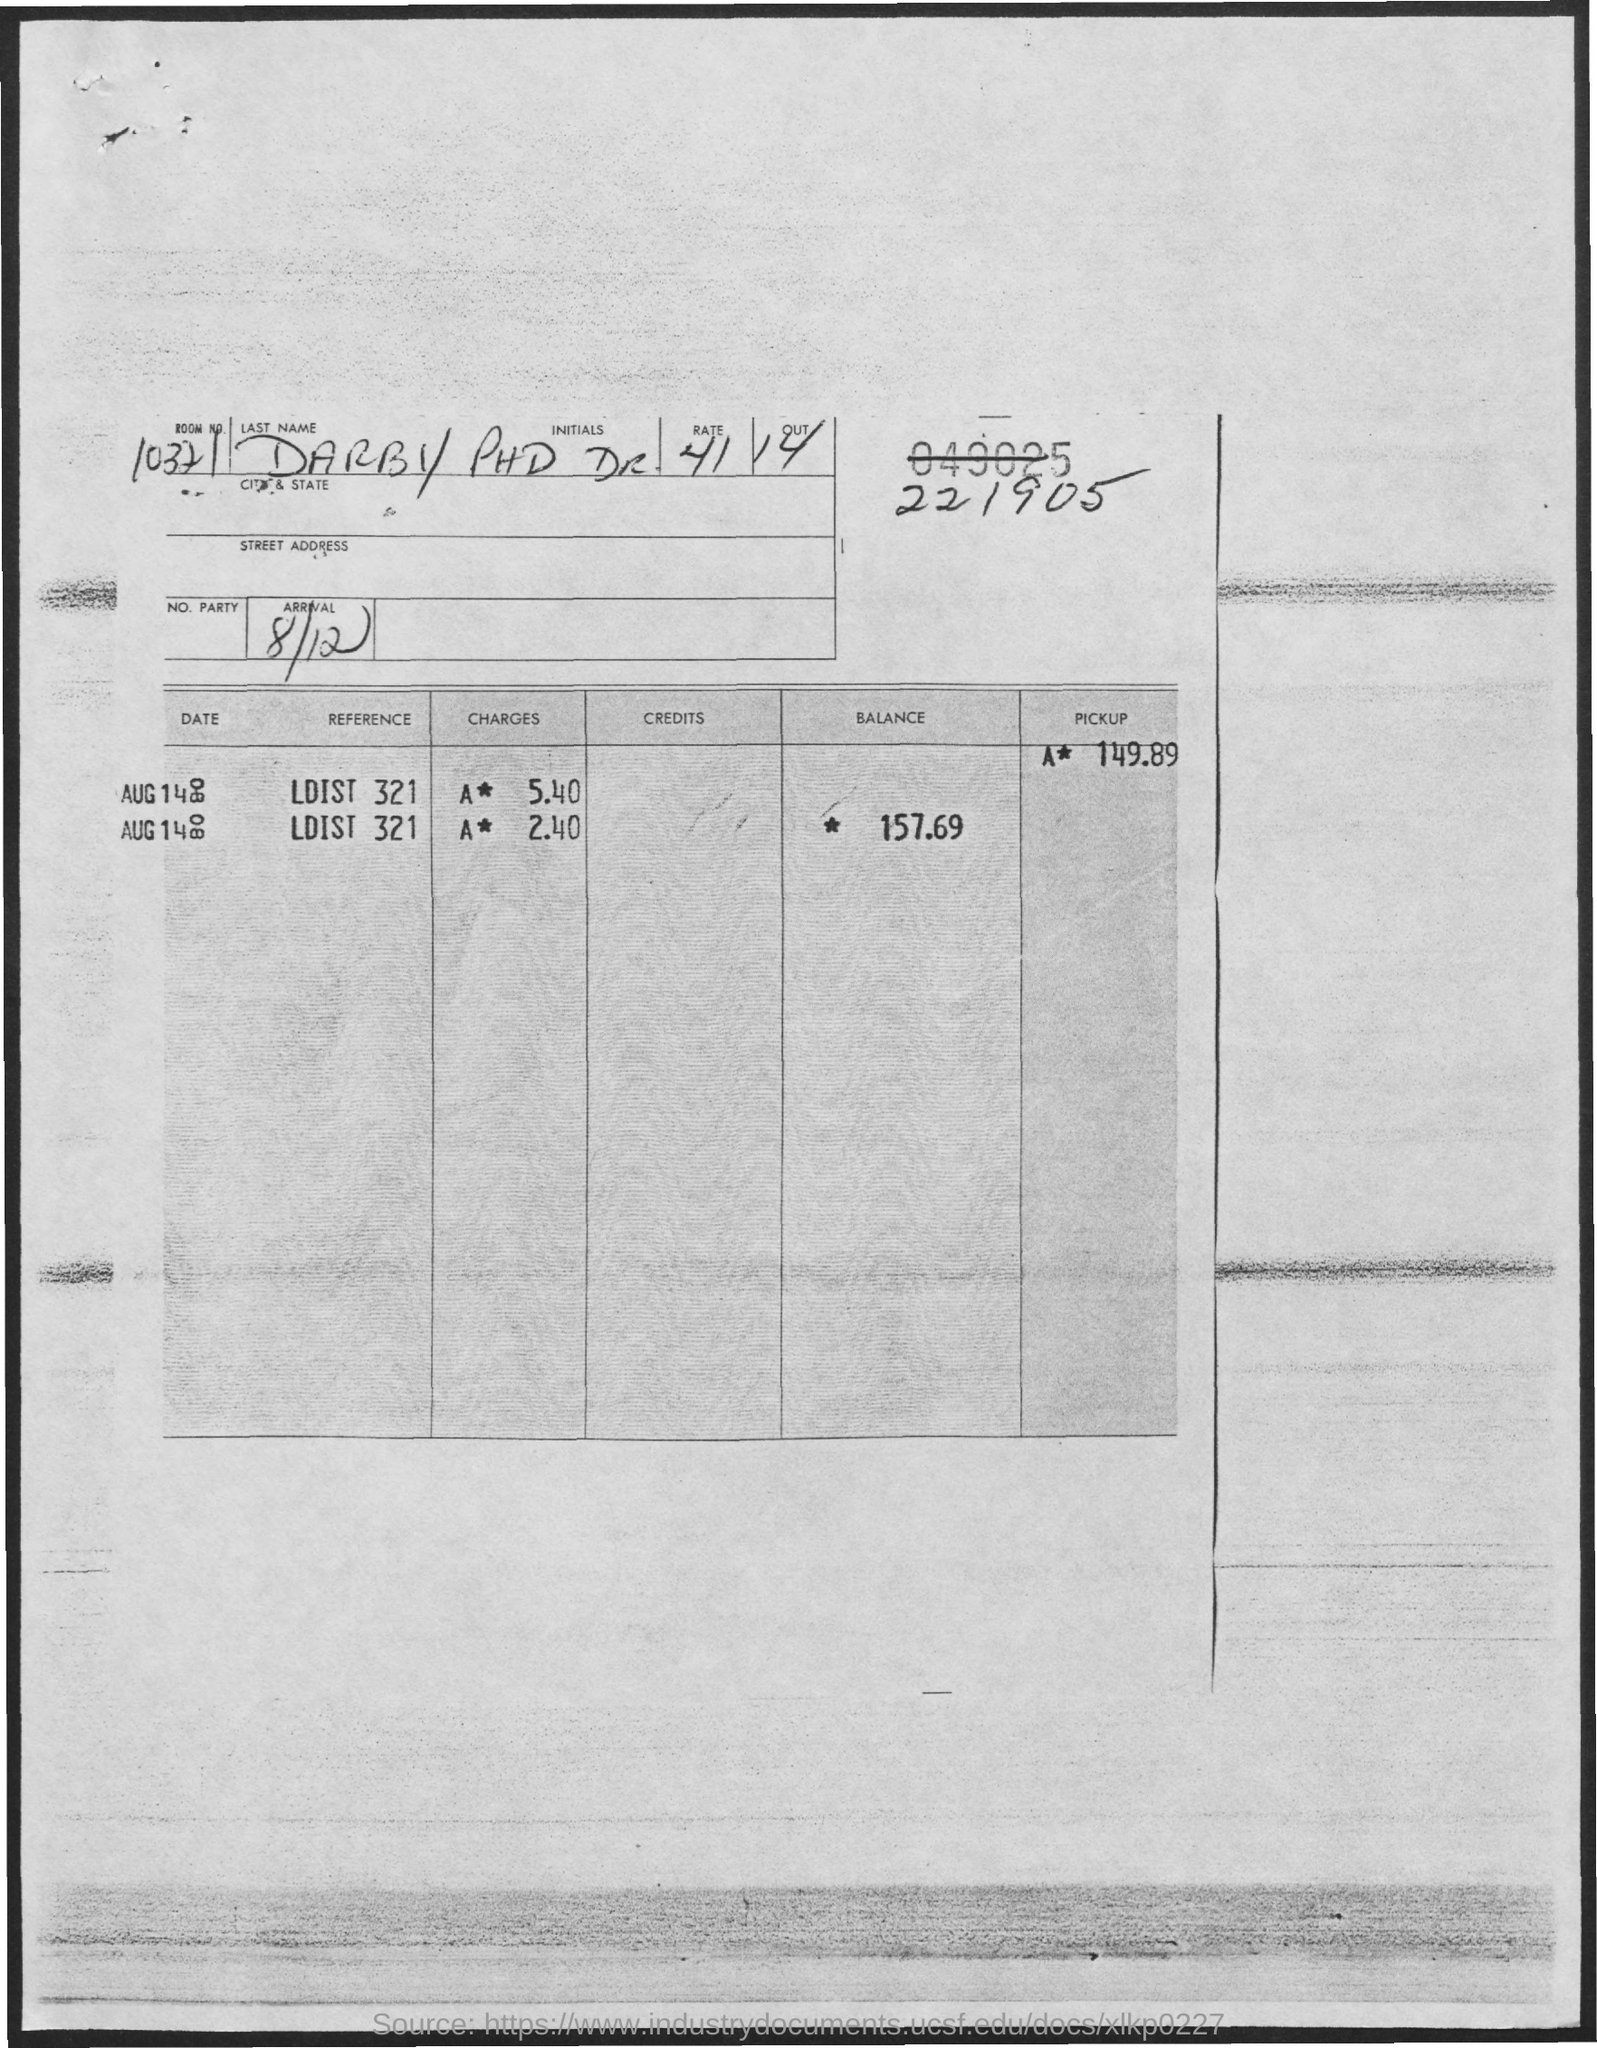Specify some key components in this picture. On what date will the arrival occur? The arrival date is August 12th, consisting of the day and month. 